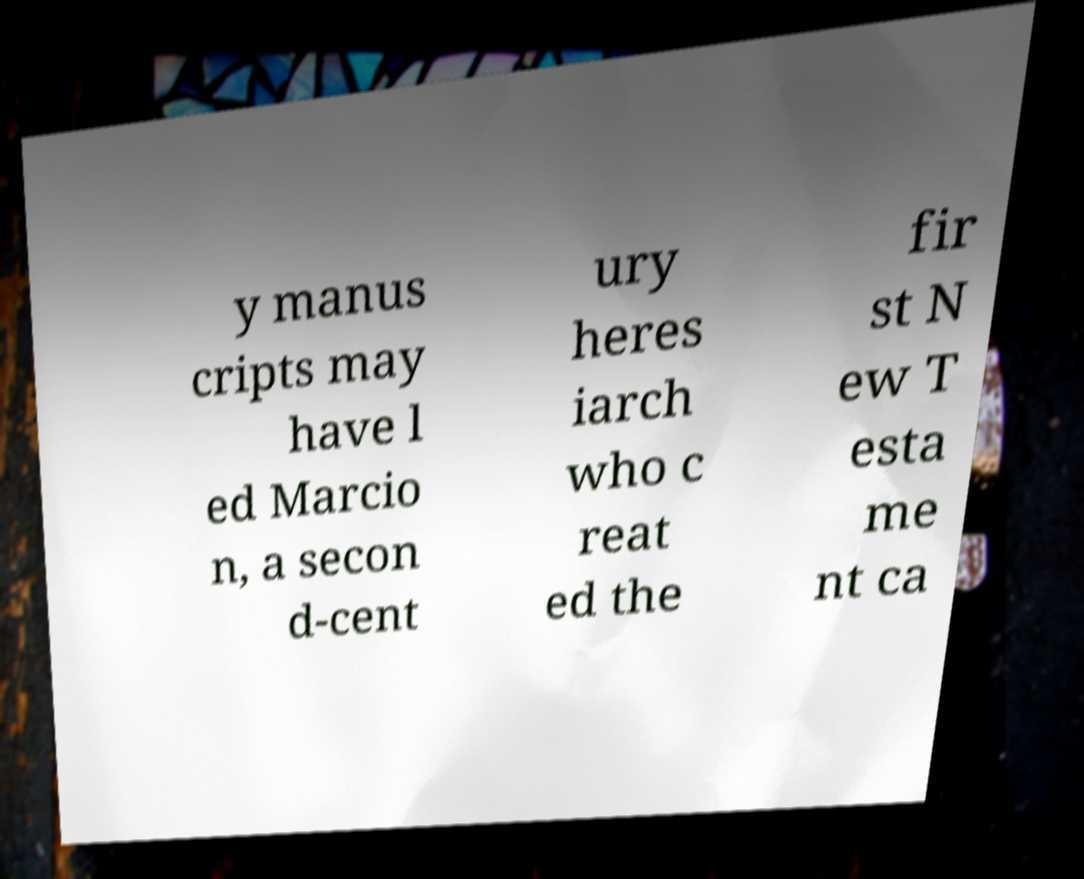Can you accurately transcribe the text from the provided image for me? y manus cripts may have l ed Marcio n, a secon d-cent ury heres iarch who c reat ed the fir st N ew T esta me nt ca 